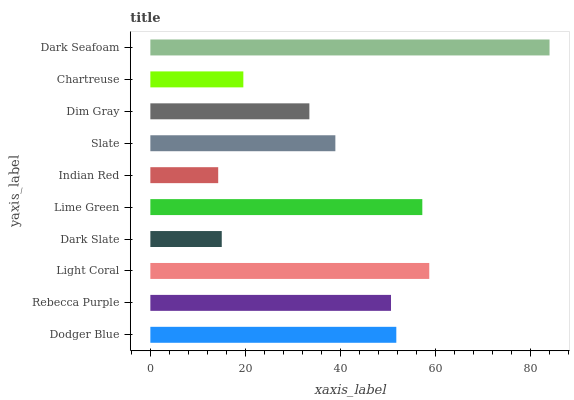Is Indian Red the minimum?
Answer yes or no. Yes. Is Dark Seafoam the maximum?
Answer yes or no. Yes. Is Rebecca Purple the minimum?
Answer yes or no. No. Is Rebecca Purple the maximum?
Answer yes or no. No. Is Dodger Blue greater than Rebecca Purple?
Answer yes or no. Yes. Is Rebecca Purple less than Dodger Blue?
Answer yes or no. Yes. Is Rebecca Purple greater than Dodger Blue?
Answer yes or no. No. Is Dodger Blue less than Rebecca Purple?
Answer yes or no. No. Is Rebecca Purple the high median?
Answer yes or no. Yes. Is Slate the low median?
Answer yes or no. Yes. Is Dark Slate the high median?
Answer yes or no. No. Is Dark Seafoam the low median?
Answer yes or no. No. 